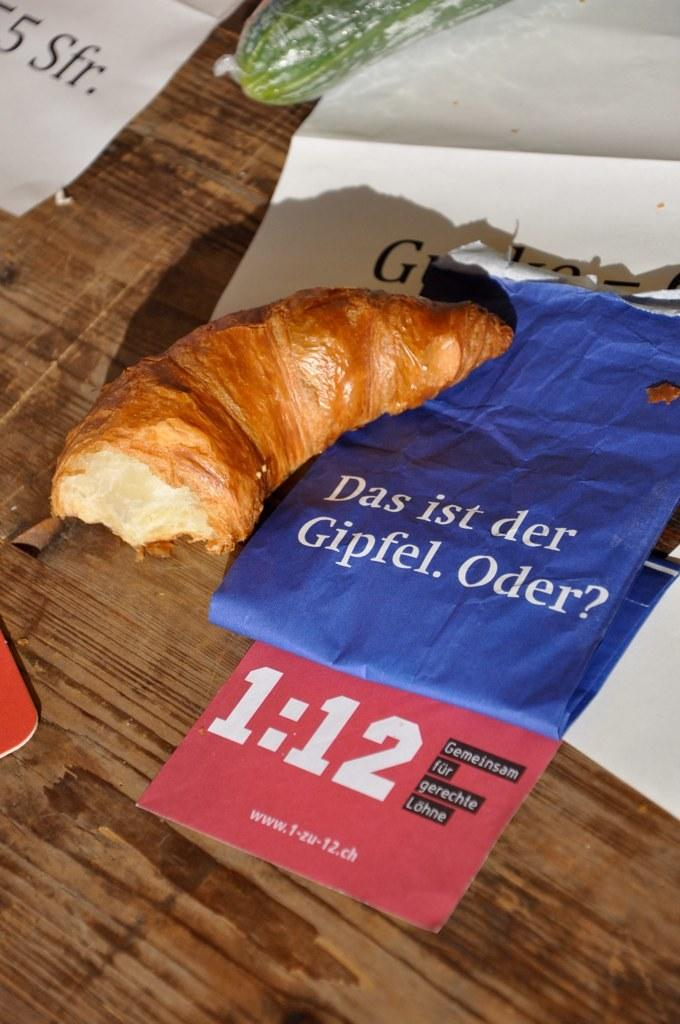What type of food is present in the image? There is food in the image, but the specific type is not mentioned. Can you identify any specific ingredients or components in the food? Yes, there is a vegetable in the image. What else is present in the image besides the food and vegetable? There is a group of papers with text in the image. What time of day is it in the image, and how does the body feel during that time? The time of day is not mentioned in the image, and there is no information about a body or its feelings. 